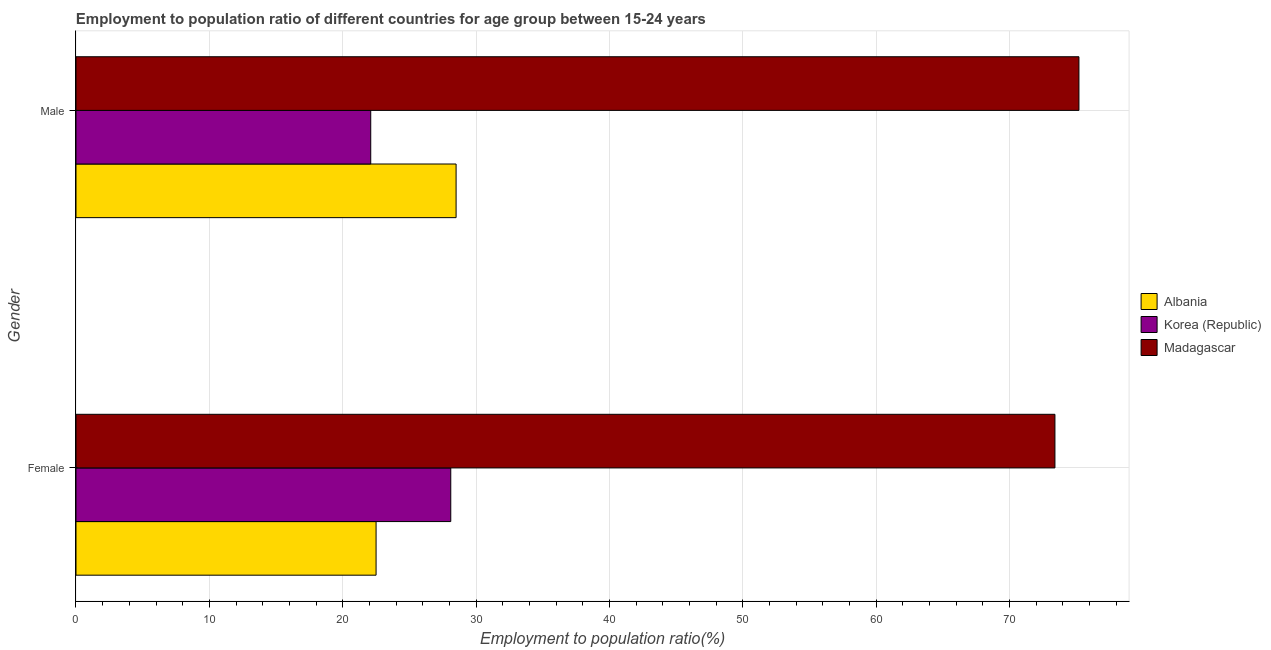How many groups of bars are there?
Your response must be concise. 2. Are the number of bars on each tick of the Y-axis equal?
Provide a succinct answer. Yes. How many bars are there on the 2nd tick from the top?
Your answer should be very brief. 3. What is the employment to population ratio(female) in Albania?
Your answer should be very brief. 22.5. Across all countries, what is the maximum employment to population ratio(female)?
Keep it short and to the point. 73.4. Across all countries, what is the minimum employment to population ratio(male)?
Ensure brevity in your answer.  22.1. In which country was the employment to population ratio(male) maximum?
Provide a short and direct response. Madagascar. In which country was the employment to population ratio(female) minimum?
Offer a very short reply. Albania. What is the total employment to population ratio(male) in the graph?
Offer a terse response. 125.8. What is the difference between the employment to population ratio(male) in Korea (Republic) and that in Madagascar?
Your answer should be compact. -53.1. What is the difference between the employment to population ratio(male) in Madagascar and the employment to population ratio(female) in Korea (Republic)?
Give a very brief answer. 47.1. What is the average employment to population ratio(male) per country?
Ensure brevity in your answer.  41.93. What is the difference between the employment to population ratio(female) and employment to population ratio(male) in Madagascar?
Offer a very short reply. -1.8. What is the ratio of the employment to population ratio(male) in Korea (Republic) to that in Albania?
Keep it short and to the point. 0.78. What does the 1st bar from the top in Male represents?
Ensure brevity in your answer.  Madagascar. What does the 1st bar from the bottom in Male represents?
Provide a succinct answer. Albania. Are all the bars in the graph horizontal?
Your response must be concise. Yes. Are the values on the major ticks of X-axis written in scientific E-notation?
Make the answer very short. No. How many legend labels are there?
Your response must be concise. 3. How are the legend labels stacked?
Your response must be concise. Vertical. What is the title of the graph?
Offer a terse response. Employment to population ratio of different countries for age group between 15-24 years. What is the Employment to population ratio(%) in Albania in Female?
Offer a terse response. 22.5. What is the Employment to population ratio(%) in Korea (Republic) in Female?
Offer a very short reply. 28.1. What is the Employment to population ratio(%) in Madagascar in Female?
Make the answer very short. 73.4. What is the Employment to population ratio(%) of Korea (Republic) in Male?
Your answer should be very brief. 22.1. What is the Employment to population ratio(%) of Madagascar in Male?
Your answer should be very brief. 75.2. Across all Gender, what is the maximum Employment to population ratio(%) of Albania?
Give a very brief answer. 28.5. Across all Gender, what is the maximum Employment to population ratio(%) in Korea (Republic)?
Your answer should be compact. 28.1. Across all Gender, what is the maximum Employment to population ratio(%) in Madagascar?
Make the answer very short. 75.2. Across all Gender, what is the minimum Employment to population ratio(%) in Albania?
Offer a very short reply. 22.5. Across all Gender, what is the minimum Employment to population ratio(%) in Korea (Republic)?
Your answer should be very brief. 22.1. Across all Gender, what is the minimum Employment to population ratio(%) of Madagascar?
Offer a terse response. 73.4. What is the total Employment to population ratio(%) of Korea (Republic) in the graph?
Keep it short and to the point. 50.2. What is the total Employment to population ratio(%) of Madagascar in the graph?
Provide a succinct answer. 148.6. What is the difference between the Employment to population ratio(%) in Albania in Female and that in Male?
Provide a succinct answer. -6. What is the difference between the Employment to population ratio(%) of Madagascar in Female and that in Male?
Your response must be concise. -1.8. What is the difference between the Employment to population ratio(%) in Albania in Female and the Employment to population ratio(%) in Korea (Republic) in Male?
Keep it short and to the point. 0.4. What is the difference between the Employment to population ratio(%) in Albania in Female and the Employment to population ratio(%) in Madagascar in Male?
Your answer should be very brief. -52.7. What is the difference between the Employment to population ratio(%) in Korea (Republic) in Female and the Employment to population ratio(%) in Madagascar in Male?
Provide a short and direct response. -47.1. What is the average Employment to population ratio(%) in Albania per Gender?
Make the answer very short. 25.5. What is the average Employment to population ratio(%) in Korea (Republic) per Gender?
Offer a very short reply. 25.1. What is the average Employment to population ratio(%) in Madagascar per Gender?
Your answer should be very brief. 74.3. What is the difference between the Employment to population ratio(%) in Albania and Employment to population ratio(%) in Madagascar in Female?
Your response must be concise. -50.9. What is the difference between the Employment to population ratio(%) of Korea (Republic) and Employment to population ratio(%) of Madagascar in Female?
Give a very brief answer. -45.3. What is the difference between the Employment to population ratio(%) in Albania and Employment to population ratio(%) in Korea (Republic) in Male?
Offer a very short reply. 6.4. What is the difference between the Employment to population ratio(%) in Albania and Employment to population ratio(%) in Madagascar in Male?
Offer a terse response. -46.7. What is the difference between the Employment to population ratio(%) in Korea (Republic) and Employment to population ratio(%) in Madagascar in Male?
Give a very brief answer. -53.1. What is the ratio of the Employment to population ratio(%) in Albania in Female to that in Male?
Provide a succinct answer. 0.79. What is the ratio of the Employment to population ratio(%) of Korea (Republic) in Female to that in Male?
Your answer should be compact. 1.27. What is the ratio of the Employment to population ratio(%) of Madagascar in Female to that in Male?
Offer a very short reply. 0.98. What is the difference between the highest and the second highest Employment to population ratio(%) in Madagascar?
Your answer should be compact. 1.8. What is the difference between the highest and the lowest Employment to population ratio(%) in Korea (Republic)?
Offer a terse response. 6. 